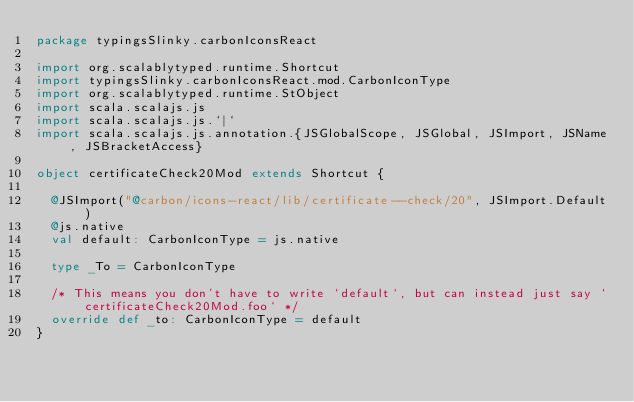Convert code to text. <code><loc_0><loc_0><loc_500><loc_500><_Scala_>package typingsSlinky.carbonIconsReact

import org.scalablytyped.runtime.Shortcut
import typingsSlinky.carbonIconsReact.mod.CarbonIconType
import org.scalablytyped.runtime.StObject
import scala.scalajs.js
import scala.scalajs.js.`|`
import scala.scalajs.js.annotation.{JSGlobalScope, JSGlobal, JSImport, JSName, JSBracketAccess}

object certificateCheck20Mod extends Shortcut {
  
  @JSImport("@carbon/icons-react/lib/certificate--check/20", JSImport.Default)
  @js.native
  val default: CarbonIconType = js.native
  
  type _To = CarbonIconType
  
  /* This means you don't have to write `default`, but can instead just say `certificateCheck20Mod.foo` */
  override def _to: CarbonIconType = default
}
</code> 